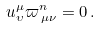<formula> <loc_0><loc_0><loc_500><loc_500>u _ { \upsilon } ^ { \mu } \varpi ^ { n } _ { \, \mu \nu } = 0 \, .</formula> 